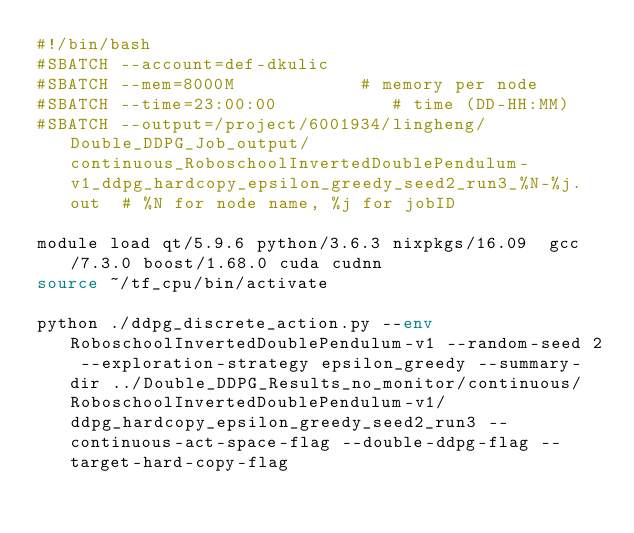Convert code to text. <code><loc_0><loc_0><loc_500><loc_500><_Bash_>#!/bin/bash
#SBATCH --account=def-dkulic
#SBATCH --mem=8000M            # memory per node
#SBATCH --time=23:00:00           # time (DD-HH:MM)
#SBATCH --output=/project/6001934/lingheng/Double_DDPG_Job_output/continuous_RoboschoolInvertedDoublePendulum-v1_ddpg_hardcopy_epsilon_greedy_seed2_run3_%N-%j.out  # %N for node name, %j for jobID

module load qt/5.9.6 python/3.6.3 nixpkgs/16.09  gcc/7.3.0 boost/1.68.0 cuda cudnn
source ~/tf_cpu/bin/activate

python ./ddpg_discrete_action.py --env RoboschoolInvertedDoublePendulum-v1 --random-seed 2 --exploration-strategy epsilon_greedy --summary-dir ../Double_DDPG_Results_no_monitor/continuous/RoboschoolInvertedDoublePendulum-v1/ddpg_hardcopy_epsilon_greedy_seed2_run3 --continuous-act-space-flag --double-ddpg-flag --target-hard-copy-flag 

</code> 